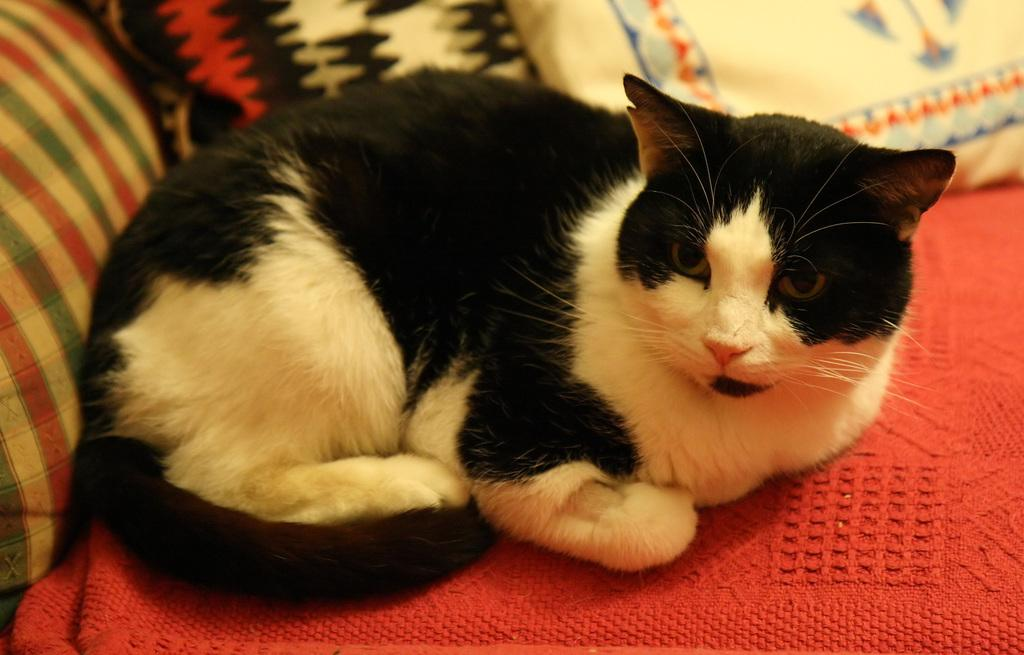What type of animal is in the image? There is a cat in the image. Can you describe the appearance of the cat? The cat is white and black in color. Where is the cat located in the image? The cat is on a couch. What is the color of the couch? The couch is colorful. What is the cat's opinion on the window in the image? There is no window present in the image, so it is not possible to determine the cat's opinion on a window. 